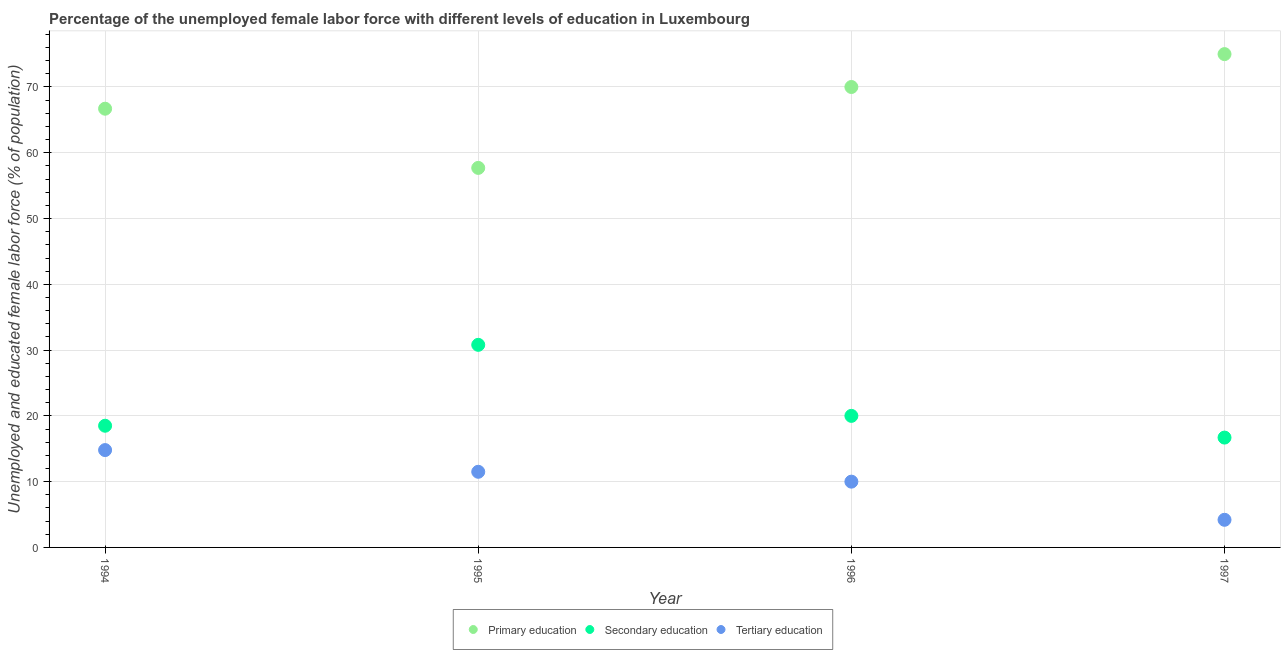Is the number of dotlines equal to the number of legend labels?
Offer a terse response. Yes. What is the percentage of female labor force who received secondary education in 1996?
Your response must be concise. 20. Across all years, what is the maximum percentage of female labor force who received secondary education?
Ensure brevity in your answer.  30.8. Across all years, what is the minimum percentage of female labor force who received tertiary education?
Make the answer very short. 4.2. In which year was the percentage of female labor force who received primary education minimum?
Give a very brief answer. 1995. What is the total percentage of female labor force who received tertiary education in the graph?
Your answer should be compact. 40.5. What is the difference between the percentage of female labor force who received primary education in 1994 and that in 1995?
Offer a terse response. 9. What is the average percentage of female labor force who received primary education per year?
Your response must be concise. 67.35. In the year 1997, what is the difference between the percentage of female labor force who received tertiary education and percentage of female labor force who received primary education?
Offer a very short reply. -70.8. In how many years, is the percentage of female labor force who received secondary education greater than 24 %?
Your response must be concise. 1. What is the ratio of the percentage of female labor force who received primary education in 1995 to that in 1996?
Your answer should be very brief. 0.82. Is the percentage of female labor force who received primary education in 1994 less than that in 1995?
Keep it short and to the point. No. What is the difference between the highest and the second highest percentage of female labor force who received tertiary education?
Ensure brevity in your answer.  3.3. What is the difference between the highest and the lowest percentage of female labor force who received tertiary education?
Your answer should be compact. 10.6. Is the sum of the percentage of female labor force who received primary education in 1994 and 1996 greater than the maximum percentage of female labor force who received tertiary education across all years?
Your response must be concise. Yes. Is the percentage of female labor force who received secondary education strictly greater than the percentage of female labor force who received tertiary education over the years?
Keep it short and to the point. Yes. How many dotlines are there?
Your response must be concise. 3. What is the difference between two consecutive major ticks on the Y-axis?
Give a very brief answer. 10. Does the graph contain any zero values?
Give a very brief answer. No. Does the graph contain grids?
Provide a succinct answer. Yes. What is the title of the graph?
Offer a terse response. Percentage of the unemployed female labor force with different levels of education in Luxembourg. Does "Natural gas sources" appear as one of the legend labels in the graph?
Your answer should be compact. No. What is the label or title of the X-axis?
Give a very brief answer. Year. What is the label or title of the Y-axis?
Your response must be concise. Unemployed and educated female labor force (% of population). What is the Unemployed and educated female labor force (% of population) in Primary education in 1994?
Give a very brief answer. 66.7. What is the Unemployed and educated female labor force (% of population) of Secondary education in 1994?
Make the answer very short. 18.5. What is the Unemployed and educated female labor force (% of population) in Tertiary education in 1994?
Keep it short and to the point. 14.8. What is the Unemployed and educated female labor force (% of population) in Primary education in 1995?
Keep it short and to the point. 57.7. What is the Unemployed and educated female labor force (% of population) of Secondary education in 1995?
Give a very brief answer. 30.8. What is the Unemployed and educated female labor force (% of population) of Primary education in 1996?
Ensure brevity in your answer.  70. What is the Unemployed and educated female labor force (% of population) of Secondary education in 1996?
Keep it short and to the point. 20. What is the Unemployed and educated female labor force (% of population) in Primary education in 1997?
Offer a very short reply. 75. What is the Unemployed and educated female labor force (% of population) of Secondary education in 1997?
Give a very brief answer. 16.7. What is the Unemployed and educated female labor force (% of population) in Tertiary education in 1997?
Offer a very short reply. 4.2. Across all years, what is the maximum Unemployed and educated female labor force (% of population) in Secondary education?
Your answer should be compact. 30.8. Across all years, what is the maximum Unemployed and educated female labor force (% of population) of Tertiary education?
Ensure brevity in your answer.  14.8. Across all years, what is the minimum Unemployed and educated female labor force (% of population) in Primary education?
Offer a very short reply. 57.7. Across all years, what is the minimum Unemployed and educated female labor force (% of population) in Secondary education?
Provide a short and direct response. 16.7. Across all years, what is the minimum Unemployed and educated female labor force (% of population) of Tertiary education?
Give a very brief answer. 4.2. What is the total Unemployed and educated female labor force (% of population) in Primary education in the graph?
Provide a succinct answer. 269.4. What is the total Unemployed and educated female labor force (% of population) in Tertiary education in the graph?
Offer a very short reply. 40.5. What is the difference between the Unemployed and educated female labor force (% of population) of Primary education in 1994 and that in 1995?
Your answer should be compact. 9. What is the difference between the Unemployed and educated female labor force (% of population) in Primary education in 1994 and that in 1996?
Provide a succinct answer. -3.3. What is the difference between the Unemployed and educated female labor force (% of population) in Primary education in 1994 and that in 1997?
Your answer should be very brief. -8.3. What is the difference between the Unemployed and educated female labor force (% of population) in Secondary education in 1994 and that in 1997?
Offer a terse response. 1.8. What is the difference between the Unemployed and educated female labor force (% of population) of Tertiary education in 1994 and that in 1997?
Provide a short and direct response. 10.6. What is the difference between the Unemployed and educated female labor force (% of population) of Primary education in 1995 and that in 1996?
Ensure brevity in your answer.  -12.3. What is the difference between the Unemployed and educated female labor force (% of population) of Tertiary education in 1995 and that in 1996?
Provide a short and direct response. 1.5. What is the difference between the Unemployed and educated female labor force (% of population) of Primary education in 1995 and that in 1997?
Your answer should be very brief. -17.3. What is the difference between the Unemployed and educated female labor force (% of population) of Secondary education in 1995 and that in 1997?
Your response must be concise. 14.1. What is the difference between the Unemployed and educated female labor force (% of population) of Primary education in 1996 and that in 1997?
Keep it short and to the point. -5. What is the difference between the Unemployed and educated female labor force (% of population) of Tertiary education in 1996 and that in 1997?
Provide a succinct answer. 5.8. What is the difference between the Unemployed and educated female labor force (% of population) of Primary education in 1994 and the Unemployed and educated female labor force (% of population) of Secondary education in 1995?
Your answer should be very brief. 35.9. What is the difference between the Unemployed and educated female labor force (% of population) in Primary education in 1994 and the Unemployed and educated female labor force (% of population) in Tertiary education in 1995?
Your answer should be compact. 55.2. What is the difference between the Unemployed and educated female labor force (% of population) of Secondary education in 1994 and the Unemployed and educated female labor force (% of population) of Tertiary education in 1995?
Your answer should be very brief. 7. What is the difference between the Unemployed and educated female labor force (% of population) of Primary education in 1994 and the Unemployed and educated female labor force (% of population) of Secondary education in 1996?
Make the answer very short. 46.7. What is the difference between the Unemployed and educated female labor force (% of population) of Primary education in 1994 and the Unemployed and educated female labor force (% of population) of Tertiary education in 1996?
Provide a short and direct response. 56.7. What is the difference between the Unemployed and educated female labor force (% of population) of Secondary education in 1994 and the Unemployed and educated female labor force (% of population) of Tertiary education in 1996?
Your answer should be compact. 8.5. What is the difference between the Unemployed and educated female labor force (% of population) in Primary education in 1994 and the Unemployed and educated female labor force (% of population) in Tertiary education in 1997?
Your answer should be compact. 62.5. What is the difference between the Unemployed and educated female labor force (% of population) of Secondary education in 1994 and the Unemployed and educated female labor force (% of population) of Tertiary education in 1997?
Offer a very short reply. 14.3. What is the difference between the Unemployed and educated female labor force (% of population) in Primary education in 1995 and the Unemployed and educated female labor force (% of population) in Secondary education in 1996?
Give a very brief answer. 37.7. What is the difference between the Unemployed and educated female labor force (% of population) of Primary education in 1995 and the Unemployed and educated female labor force (% of population) of Tertiary education in 1996?
Provide a succinct answer. 47.7. What is the difference between the Unemployed and educated female labor force (% of population) of Secondary education in 1995 and the Unemployed and educated female labor force (% of population) of Tertiary education in 1996?
Give a very brief answer. 20.8. What is the difference between the Unemployed and educated female labor force (% of population) in Primary education in 1995 and the Unemployed and educated female labor force (% of population) in Secondary education in 1997?
Offer a terse response. 41. What is the difference between the Unemployed and educated female labor force (% of population) in Primary education in 1995 and the Unemployed and educated female labor force (% of population) in Tertiary education in 1997?
Provide a short and direct response. 53.5. What is the difference between the Unemployed and educated female labor force (% of population) of Secondary education in 1995 and the Unemployed and educated female labor force (% of population) of Tertiary education in 1997?
Provide a succinct answer. 26.6. What is the difference between the Unemployed and educated female labor force (% of population) of Primary education in 1996 and the Unemployed and educated female labor force (% of population) of Secondary education in 1997?
Provide a succinct answer. 53.3. What is the difference between the Unemployed and educated female labor force (% of population) of Primary education in 1996 and the Unemployed and educated female labor force (% of population) of Tertiary education in 1997?
Provide a short and direct response. 65.8. What is the average Unemployed and educated female labor force (% of population) of Primary education per year?
Provide a short and direct response. 67.35. What is the average Unemployed and educated female labor force (% of population) in Tertiary education per year?
Give a very brief answer. 10.12. In the year 1994, what is the difference between the Unemployed and educated female labor force (% of population) in Primary education and Unemployed and educated female labor force (% of population) in Secondary education?
Your response must be concise. 48.2. In the year 1994, what is the difference between the Unemployed and educated female labor force (% of population) of Primary education and Unemployed and educated female labor force (% of population) of Tertiary education?
Your response must be concise. 51.9. In the year 1995, what is the difference between the Unemployed and educated female labor force (% of population) in Primary education and Unemployed and educated female labor force (% of population) in Secondary education?
Give a very brief answer. 26.9. In the year 1995, what is the difference between the Unemployed and educated female labor force (% of population) in Primary education and Unemployed and educated female labor force (% of population) in Tertiary education?
Keep it short and to the point. 46.2. In the year 1995, what is the difference between the Unemployed and educated female labor force (% of population) of Secondary education and Unemployed and educated female labor force (% of population) of Tertiary education?
Your response must be concise. 19.3. In the year 1996, what is the difference between the Unemployed and educated female labor force (% of population) of Secondary education and Unemployed and educated female labor force (% of population) of Tertiary education?
Provide a succinct answer. 10. In the year 1997, what is the difference between the Unemployed and educated female labor force (% of population) in Primary education and Unemployed and educated female labor force (% of population) in Secondary education?
Your answer should be compact. 58.3. In the year 1997, what is the difference between the Unemployed and educated female labor force (% of population) in Primary education and Unemployed and educated female labor force (% of population) in Tertiary education?
Provide a succinct answer. 70.8. In the year 1997, what is the difference between the Unemployed and educated female labor force (% of population) in Secondary education and Unemployed and educated female labor force (% of population) in Tertiary education?
Give a very brief answer. 12.5. What is the ratio of the Unemployed and educated female labor force (% of population) of Primary education in 1994 to that in 1995?
Make the answer very short. 1.16. What is the ratio of the Unemployed and educated female labor force (% of population) in Secondary education in 1994 to that in 1995?
Provide a succinct answer. 0.6. What is the ratio of the Unemployed and educated female labor force (% of population) of Tertiary education in 1994 to that in 1995?
Offer a terse response. 1.29. What is the ratio of the Unemployed and educated female labor force (% of population) in Primary education in 1994 to that in 1996?
Your response must be concise. 0.95. What is the ratio of the Unemployed and educated female labor force (% of population) of Secondary education in 1994 to that in 1996?
Give a very brief answer. 0.93. What is the ratio of the Unemployed and educated female labor force (% of population) in Tertiary education in 1994 to that in 1996?
Your answer should be very brief. 1.48. What is the ratio of the Unemployed and educated female labor force (% of population) of Primary education in 1994 to that in 1997?
Make the answer very short. 0.89. What is the ratio of the Unemployed and educated female labor force (% of population) of Secondary education in 1994 to that in 1997?
Give a very brief answer. 1.11. What is the ratio of the Unemployed and educated female labor force (% of population) of Tertiary education in 1994 to that in 1997?
Make the answer very short. 3.52. What is the ratio of the Unemployed and educated female labor force (% of population) of Primary education in 1995 to that in 1996?
Make the answer very short. 0.82. What is the ratio of the Unemployed and educated female labor force (% of population) of Secondary education in 1995 to that in 1996?
Offer a very short reply. 1.54. What is the ratio of the Unemployed and educated female labor force (% of population) in Tertiary education in 1995 to that in 1996?
Offer a terse response. 1.15. What is the ratio of the Unemployed and educated female labor force (% of population) in Primary education in 1995 to that in 1997?
Offer a very short reply. 0.77. What is the ratio of the Unemployed and educated female labor force (% of population) in Secondary education in 1995 to that in 1997?
Keep it short and to the point. 1.84. What is the ratio of the Unemployed and educated female labor force (% of population) of Tertiary education in 1995 to that in 1997?
Your response must be concise. 2.74. What is the ratio of the Unemployed and educated female labor force (% of population) in Secondary education in 1996 to that in 1997?
Give a very brief answer. 1.2. What is the ratio of the Unemployed and educated female labor force (% of population) in Tertiary education in 1996 to that in 1997?
Offer a terse response. 2.38. What is the difference between the highest and the lowest Unemployed and educated female labor force (% of population) in Secondary education?
Provide a succinct answer. 14.1. What is the difference between the highest and the lowest Unemployed and educated female labor force (% of population) of Tertiary education?
Give a very brief answer. 10.6. 